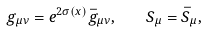<formula> <loc_0><loc_0><loc_500><loc_500>g _ { \mu \nu } = e ^ { 2 \sigma ( x ) } \bar { g } _ { \mu \nu } , \quad S _ { \mu } = \bar { S } _ { \mu } ,</formula> 